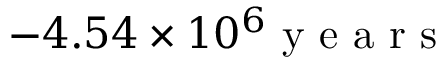Convert formula to latex. <formula><loc_0><loc_0><loc_500><loc_500>- 4 . 5 4 \times 1 0 ^ { 6 } y e a r s</formula> 